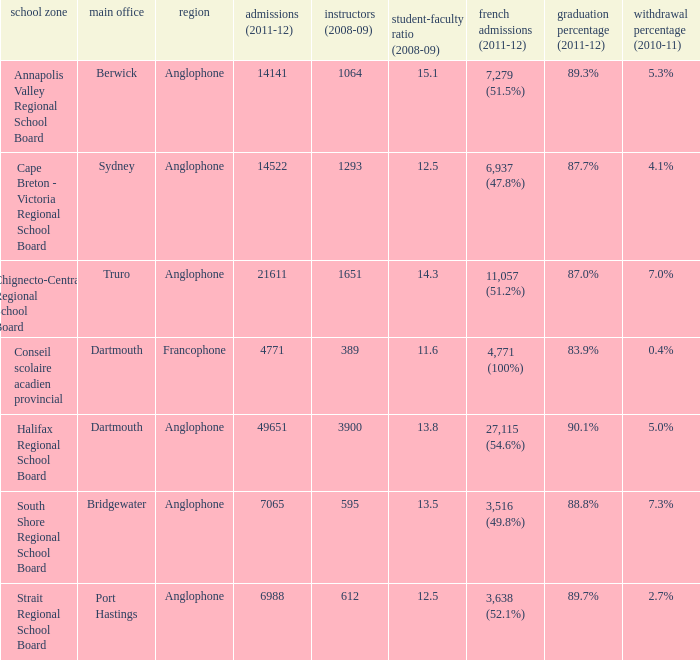What is the withdrawal rate for the school district with a graduation rate of 89.3%? 5.3%. 